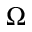<formula> <loc_0><loc_0><loc_500><loc_500>\Omega</formula> 